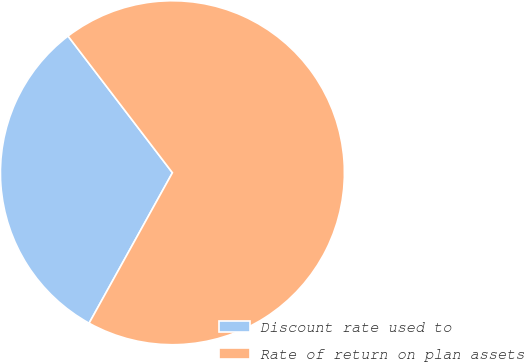Convert chart. <chart><loc_0><loc_0><loc_500><loc_500><pie_chart><fcel>Discount rate used to<fcel>Rate of return on plan assets<nl><fcel>31.57%<fcel>68.43%<nl></chart> 